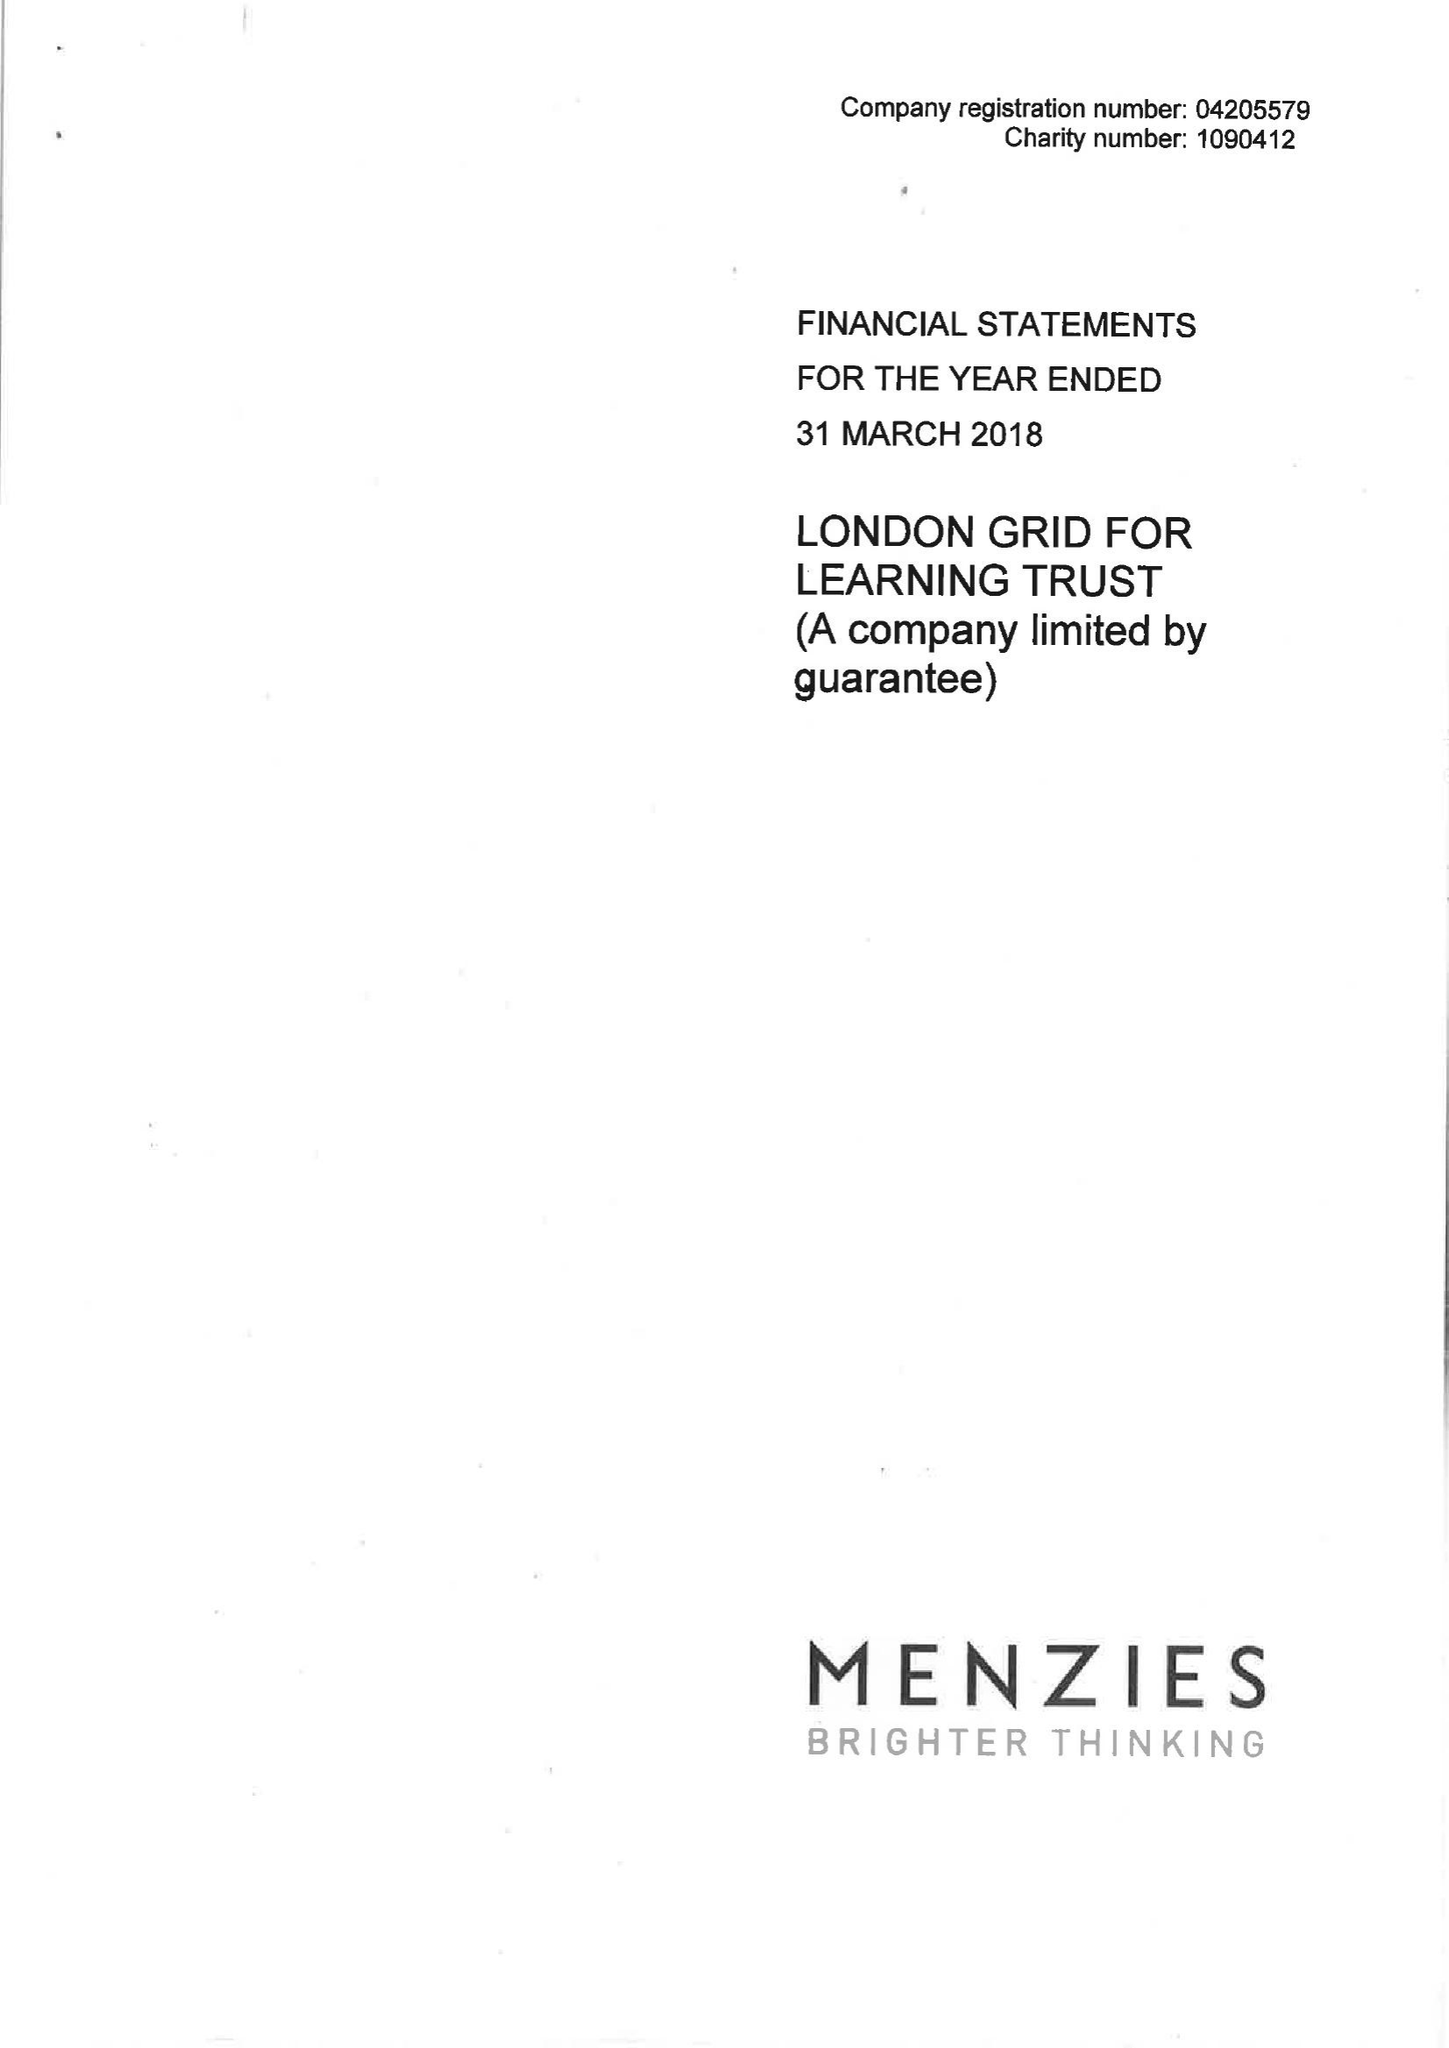What is the value for the charity_number?
Answer the question using a single word or phrase. 1090412 